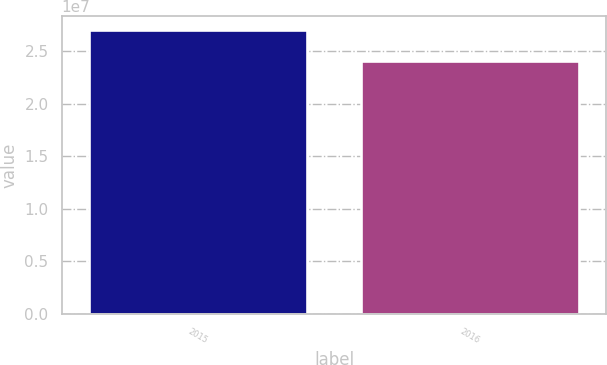<chart> <loc_0><loc_0><loc_500><loc_500><bar_chart><fcel>2015<fcel>2016<nl><fcel>2.7e+07<fcel>2.412e+07<nl></chart> 